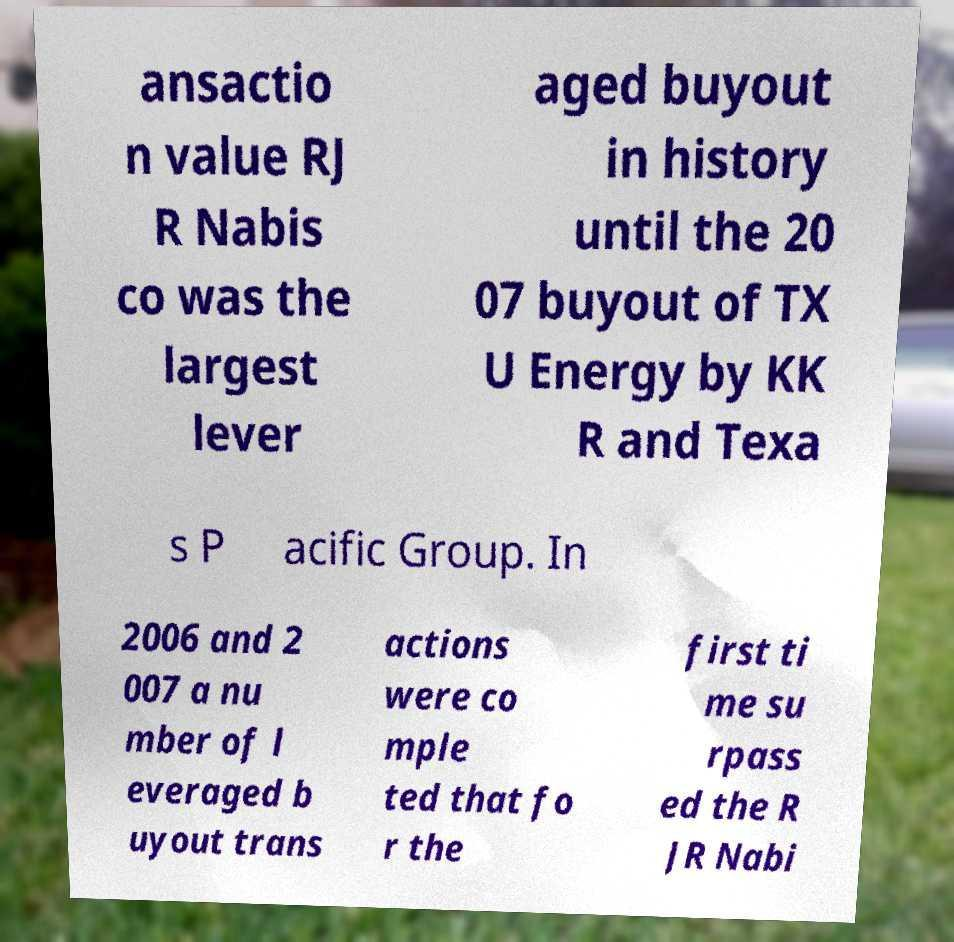Can you accurately transcribe the text from the provided image for me? ansactio n value RJ R Nabis co was the largest lever aged buyout in history until the 20 07 buyout of TX U Energy by KK R and Texa s P acific Group. In 2006 and 2 007 a nu mber of l everaged b uyout trans actions were co mple ted that fo r the first ti me su rpass ed the R JR Nabi 